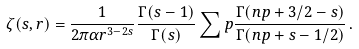<formula> <loc_0><loc_0><loc_500><loc_500>\zeta ( s , r ) = \frac { 1 } { 2 \pi \alpha r ^ { 3 - 2 s } } \frac { \Gamma ( s - 1 ) } { \Gamma ( s ) } \sum p \frac { \Gamma ( n p + 3 / 2 - s ) } { \Gamma ( n p + s - 1 / 2 ) } \, .</formula> 